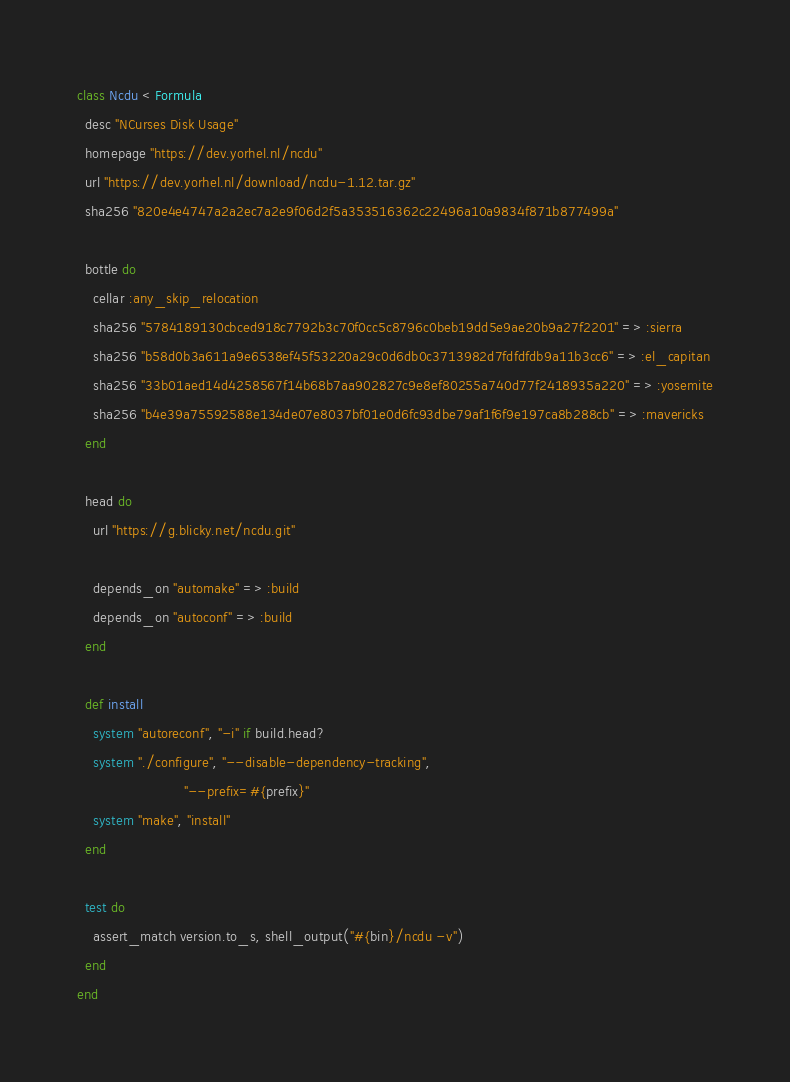<code> <loc_0><loc_0><loc_500><loc_500><_Ruby_>class Ncdu < Formula
  desc "NCurses Disk Usage"
  homepage "https://dev.yorhel.nl/ncdu"
  url "https://dev.yorhel.nl/download/ncdu-1.12.tar.gz"
  sha256 "820e4e4747a2a2ec7a2e9f06d2f5a353516362c22496a10a9834f871b877499a"

  bottle do
    cellar :any_skip_relocation
    sha256 "5784189130cbced918c7792b3c70f0cc5c8796c0beb19dd5e9ae20b9a27f2201" => :sierra
    sha256 "b58d0b3a611a9e6538ef45f53220a29c0d6db0c3713982d7fdfdfdb9a11b3cc6" => :el_capitan
    sha256 "33b01aed14d4258567f14b68b7aa902827c9e8ef80255a740d77f2418935a220" => :yosemite
    sha256 "b4e39a75592588e134de07e8037bf01e0d6fc93dbe79af1f6f9e197ca8b288cb" => :mavericks
  end

  head do
    url "https://g.blicky.net/ncdu.git"

    depends_on "automake" => :build
    depends_on "autoconf" => :build
  end

  def install
    system "autoreconf", "-i" if build.head?
    system "./configure", "--disable-dependency-tracking",
                          "--prefix=#{prefix}"
    system "make", "install"
  end

  test do
    assert_match version.to_s, shell_output("#{bin}/ncdu -v")
  end
end
</code> 